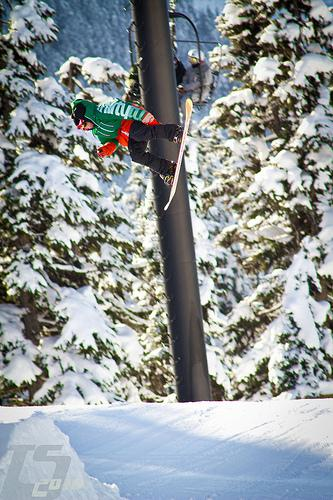Question: where was the picture taken?
Choices:
A. Beach resort.
B. At a ski resort.
C. Spa.
D. Hotel.
Answer with the letter. Answer: B Question: who is in the picture?
Choices:
A. A skiier.
B. A detective.
C. A snowboarder.
D. A fisher.
Answer with the letter. Answer: C 